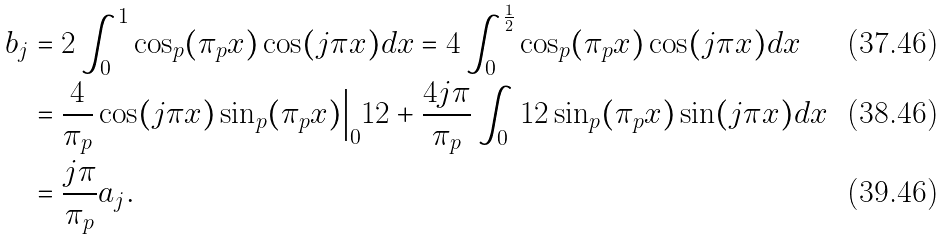<formula> <loc_0><loc_0><loc_500><loc_500>b _ { j } & = 2 \int _ { 0 } ^ { 1 } \cos _ { p } ( \pi _ { p } x ) \cos ( j \pi x ) d x = 4 \int _ { 0 } ^ { \frac { 1 } { 2 } } \cos _ { p } ( \pi _ { p } x ) \cos ( j \pi x ) d x \\ & = \frac { 4 } { \pi _ { p } } \cos ( j \pi x ) \sin _ { p } ( \pi _ { p } x ) \Big | _ { 0 } ^ { } { 1 } 2 + \frac { 4 j \pi } { \pi _ { p } } \int _ { 0 } ^ { } { 1 } 2 \sin _ { p } ( \pi _ { p } x ) \sin ( j \pi x ) d x \\ & = \frac { j \pi } { \pi _ { p } } a _ { j } .</formula> 